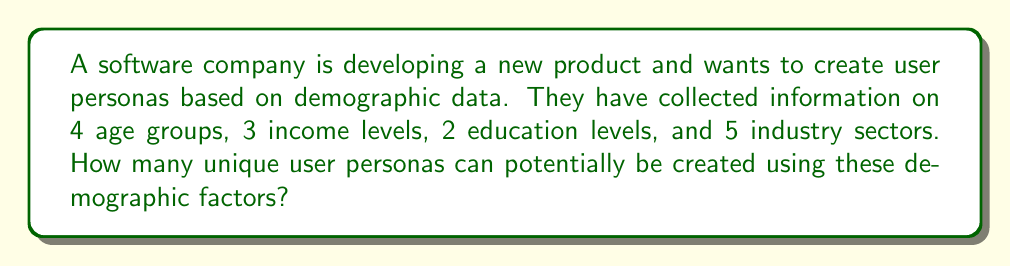Can you solve this math problem? To solve this problem, we need to use the multiplication principle of counting. This principle states that if we have independent choices for different categories, we multiply the number of options for each category to get the total number of possible combinations.

Let's break down the given information:
1. Age groups: 4 options
2. Income levels: 3 options
3. Education levels: 2 options
4. Industry sectors: 5 options

To calculate the total number of unique user personas, we multiply these numbers together:

$$\text{Total personas} = 4 \times 3 \times 2 \times 5$$

Now, let's perform the calculation:

$$\begin{align}
\text{Total personas} &= 4 \times 3 \times 2 \times 5 \\
&= 12 \times 2 \times 5 \\
&= 24 \times 5 \\
&= 120
\end{align}$$

Therefore, the company can potentially create 120 unique user personas based on the given demographic factors.
Answer: 120 personas 